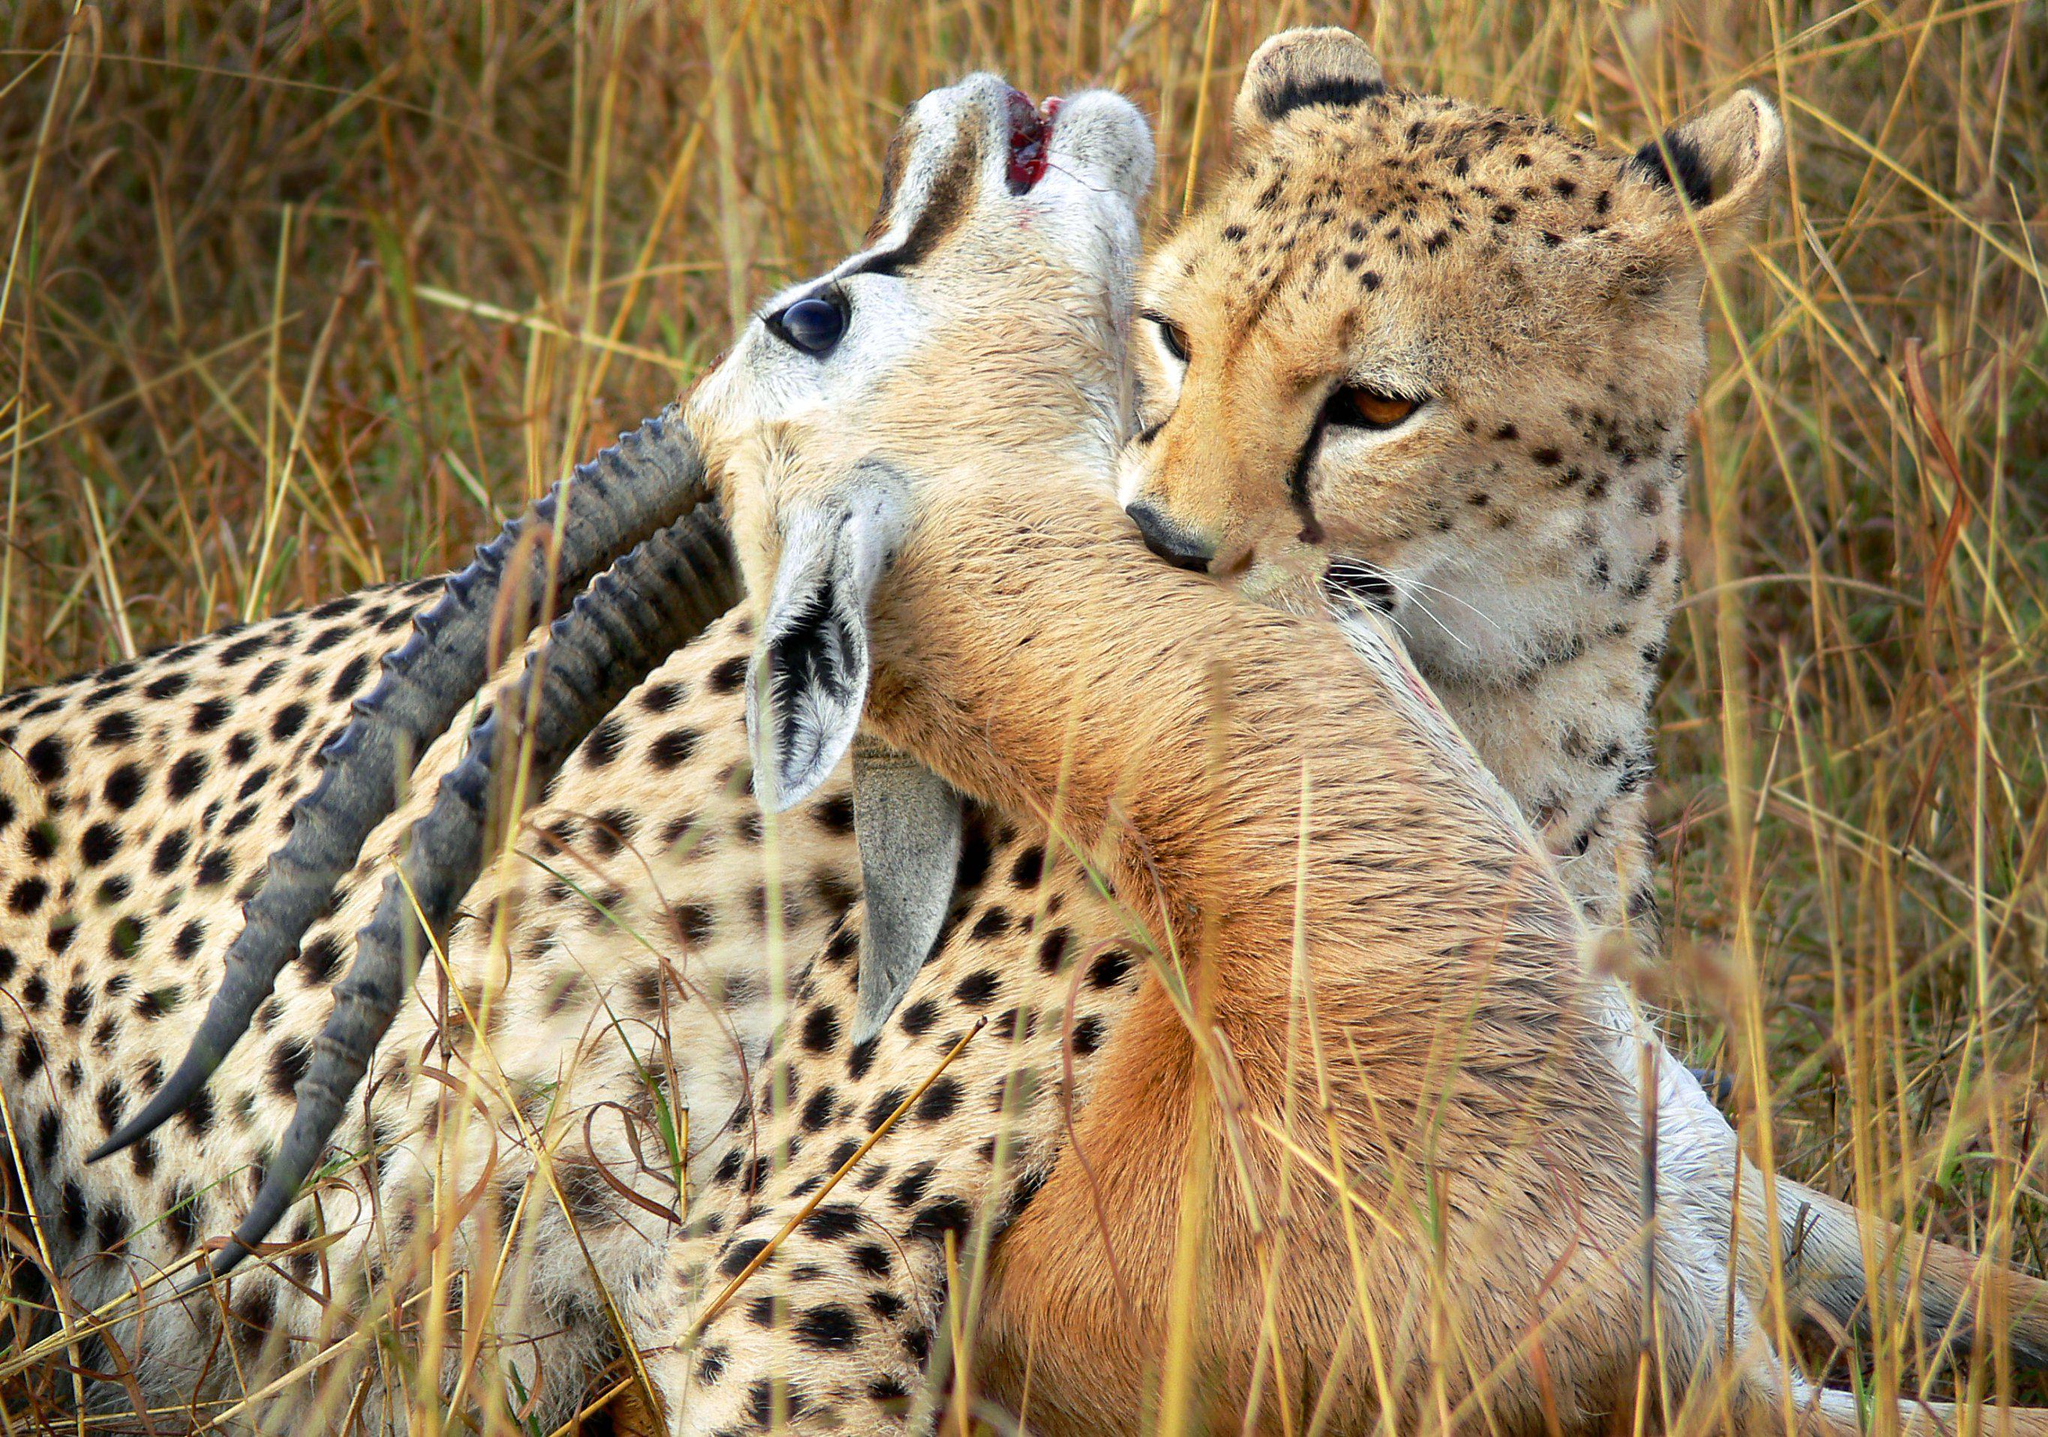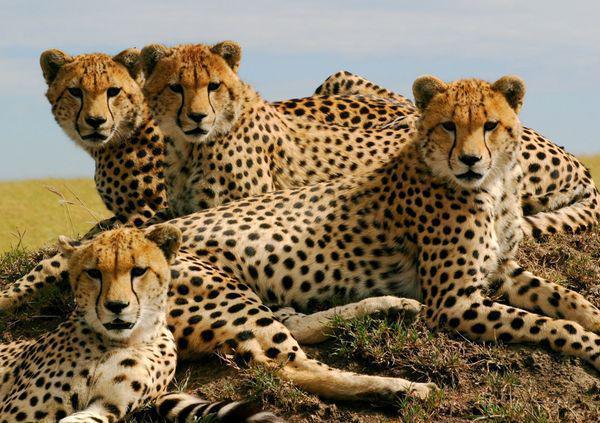The first image is the image on the left, the second image is the image on the right. Considering the images on both sides, is "One of the large cats is biting an antelope." valid? Answer yes or no. Yes. The first image is the image on the left, the second image is the image on the right. For the images shown, is this caption "The image on the left contains at least one cheetah eating an antelope." true? Answer yes or no. Yes. 